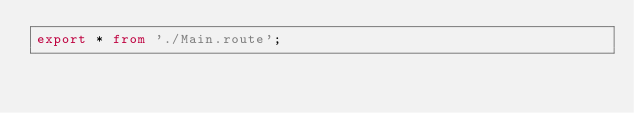Convert code to text. <code><loc_0><loc_0><loc_500><loc_500><_TypeScript_>export * from './Main.route';
</code> 